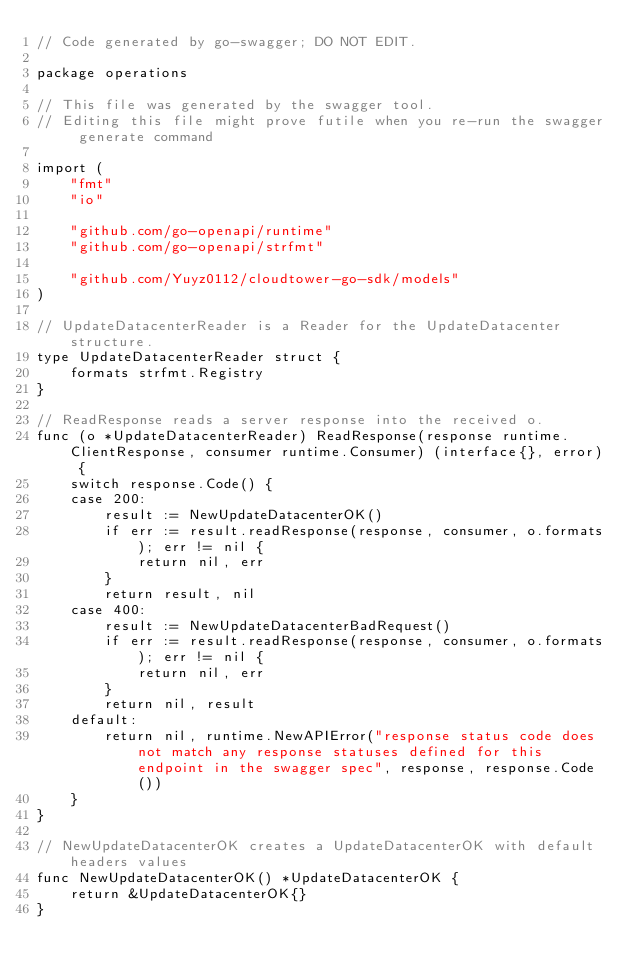<code> <loc_0><loc_0><loc_500><loc_500><_Go_>// Code generated by go-swagger; DO NOT EDIT.

package operations

// This file was generated by the swagger tool.
// Editing this file might prove futile when you re-run the swagger generate command

import (
	"fmt"
	"io"

	"github.com/go-openapi/runtime"
	"github.com/go-openapi/strfmt"

	"github.com/Yuyz0112/cloudtower-go-sdk/models"
)

// UpdateDatacenterReader is a Reader for the UpdateDatacenter structure.
type UpdateDatacenterReader struct {
	formats strfmt.Registry
}

// ReadResponse reads a server response into the received o.
func (o *UpdateDatacenterReader) ReadResponse(response runtime.ClientResponse, consumer runtime.Consumer) (interface{}, error) {
	switch response.Code() {
	case 200:
		result := NewUpdateDatacenterOK()
		if err := result.readResponse(response, consumer, o.formats); err != nil {
			return nil, err
		}
		return result, nil
	case 400:
		result := NewUpdateDatacenterBadRequest()
		if err := result.readResponse(response, consumer, o.formats); err != nil {
			return nil, err
		}
		return nil, result
	default:
		return nil, runtime.NewAPIError("response status code does not match any response statuses defined for this endpoint in the swagger spec", response, response.Code())
	}
}

// NewUpdateDatacenterOK creates a UpdateDatacenterOK with default headers values
func NewUpdateDatacenterOK() *UpdateDatacenterOK {
	return &UpdateDatacenterOK{}
}
</code> 